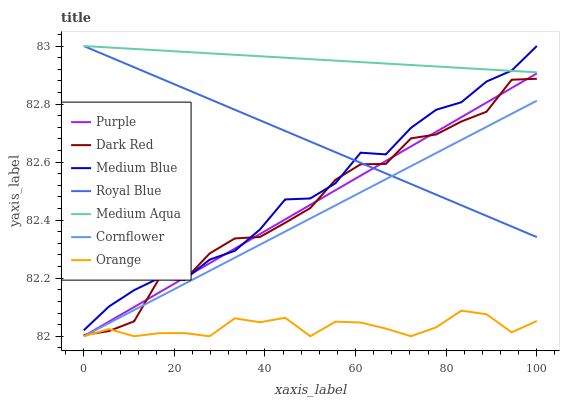Does Orange have the minimum area under the curve?
Answer yes or no. Yes. Does Medium Aqua have the maximum area under the curve?
Answer yes or no. Yes. Does Purple have the minimum area under the curve?
Answer yes or no. No. Does Purple have the maximum area under the curve?
Answer yes or no. No. Is Purple the smoothest?
Answer yes or no. Yes. Is Dark Red the roughest?
Answer yes or no. Yes. Is Dark Red the smoothest?
Answer yes or no. No. Is Purple the roughest?
Answer yes or no. No. Does Cornflower have the lowest value?
Answer yes or no. Yes. Does Dark Red have the lowest value?
Answer yes or no. No. Does Medium Aqua have the highest value?
Answer yes or no. Yes. Does Purple have the highest value?
Answer yes or no. No. Is Orange less than Royal Blue?
Answer yes or no. Yes. Is Royal Blue greater than Orange?
Answer yes or no. Yes. Does Orange intersect Cornflower?
Answer yes or no. Yes. Is Orange less than Cornflower?
Answer yes or no. No. Is Orange greater than Cornflower?
Answer yes or no. No. Does Orange intersect Royal Blue?
Answer yes or no. No. 